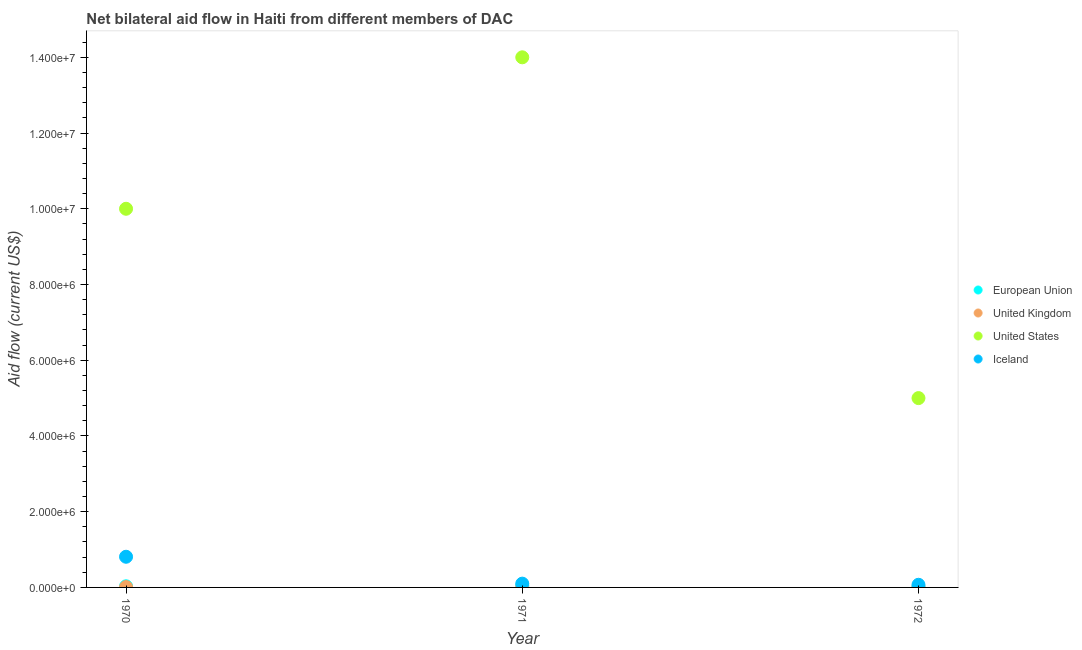What is the amount of aid given by us in 1972?
Keep it short and to the point. 5.00e+06. Across all years, what is the maximum amount of aid given by uk?
Provide a succinct answer. 10000. Across all years, what is the minimum amount of aid given by us?
Give a very brief answer. 5.00e+06. In which year was the amount of aid given by eu maximum?
Give a very brief answer. 1971. What is the total amount of aid given by eu in the graph?
Provide a succinct answer. 9.00e+04. What is the difference between the amount of aid given by iceland in 1970 and that in 1971?
Offer a terse response. 7.10e+05. What is the difference between the amount of aid given by iceland in 1972 and the amount of aid given by us in 1971?
Make the answer very short. -1.39e+07. What is the average amount of aid given by iceland per year?
Offer a very short reply. 3.27e+05. In the year 1970, what is the difference between the amount of aid given by uk and amount of aid given by us?
Ensure brevity in your answer.  -9.99e+06. What is the ratio of the amount of aid given by uk in 1970 to that in 1971?
Give a very brief answer. 1. Is the difference between the amount of aid given by eu in 1970 and 1971 greater than the difference between the amount of aid given by uk in 1970 and 1971?
Your answer should be compact. No. What is the difference between the highest and the second highest amount of aid given by eu?
Keep it short and to the point. 2.00e+04. Is the sum of the amount of aid given by iceland in 1970 and 1972 greater than the maximum amount of aid given by us across all years?
Ensure brevity in your answer.  No. Is it the case that in every year, the sum of the amount of aid given by uk and amount of aid given by iceland is greater than the sum of amount of aid given by eu and amount of aid given by us?
Your answer should be compact. Yes. Is the amount of aid given by eu strictly less than the amount of aid given by uk over the years?
Keep it short and to the point. No. How many years are there in the graph?
Offer a very short reply. 3. What is the difference between two consecutive major ticks on the Y-axis?
Your answer should be very brief. 2.00e+06. Are the values on the major ticks of Y-axis written in scientific E-notation?
Give a very brief answer. Yes. Where does the legend appear in the graph?
Your response must be concise. Center right. What is the title of the graph?
Provide a succinct answer. Net bilateral aid flow in Haiti from different members of DAC. What is the label or title of the X-axis?
Make the answer very short. Year. What is the label or title of the Y-axis?
Make the answer very short. Aid flow (current US$). What is the Aid flow (current US$) of United Kingdom in 1970?
Provide a succinct answer. 10000. What is the Aid flow (current US$) of United States in 1970?
Offer a terse response. 1.00e+07. What is the Aid flow (current US$) of Iceland in 1970?
Your response must be concise. 8.10e+05. What is the Aid flow (current US$) of United Kingdom in 1971?
Your answer should be compact. 10000. What is the Aid flow (current US$) of United States in 1971?
Keep it short and to the point. 1.40e+07. What is the Aid flow (current US$) of Iceland in 1971?
Provide a succinct answer. 1.00e+05. What is the Aid flow (current US$) in Iceland in 1972?
Provide a succinct answer. 7.00e+04. Across all years, what is the maximum Aid flow (current US$) of United States?
Your answer should be compact. 1.40e+07. Across all years, what is the maximum Aid flow (current US$) of Iceland?
Offer a terse response. 8.10e+05. Across all years, what is the minimum Aid flow (current US$) of European Union?
Provide a succinct answer. 10000. Across all years, what is the minimum Aid flow (current US$) of Iceland?
Provide a succinct answer. 7.00e+04. What is the total Aid flow (current US$) in United States in the graph?
Provide a succinct answer. 2.90e+07. What is the total Aid flow (current US$) in Iceland in the graph?
Keep it short and to the point. 9.80e+05. What is the difference between the Aid flow (current US$) in United States in 1970 and that in 1971?
Provide a short and direct response. -4.00e+06. What is the difference between the Aid flow (current US$) of Iceland in 1970 and that in 1971?
Provide a short and direct response. 7.10e+05. What is the difference between the Aid flow (current US$) of United Kingdom in 1970 and that in 1972?
Give a very brief answer. 0. What is the difference between the Aid flow (current US$) in Iceland in 1970 and that in 1972?
Your response must be concise. 7.40e+05. What is the difference between the Aid flow (current US$) of United States in 1971 and that in 1972?
Your answer should be very brief. 9.00e+06. What is the difference between the Aid flow (current US$) of European Union in 1970 and the Aid flow (current US$) of United Kingdom in 1971?
Offer a terse response. 2.00e+04. What is the difference between the Aid flow (current US$) of European Union in 1970 and the Aid flow (current US$) of United States in 1971?
Make the answer very short. -1.40e+07. What is the difference between the Aid flow (current US$) of European Union in 1970 and the Aid flow (current US$) of Iceland in 1971?
Ensure brevity in your answer.  -7.00e+04. What is the difference between the Aid flow (current US$) in United Kingdom in 1970 and the Aid flow (current US$) in United States in 1971?
Keep it short and to the point. -1.40e+07. What is the difference between the Aid flow (current US$) in United Kingdom in 1970 and the Aid flow (current US$) in Iceland in 1971?
Give a very brief answer. -9.00e+04. What is the difference between the Aid flow (current US$) in United States in 1970 and the Aid flow (current US$) in Iceland in 1971?
Ensure brevity in your answer.  9.90e+06. What is the difference between the Aid flow (current US$) of European Union in 1970 and the Aid flow (current US$) of United States in 1972?
Offer a very short reply. -4.97e+06. What is the difference between the Aid flow (current US$) of European Union in 1970 and the Aid flow (current US$) of Iceland in 1972?
Your answer should be very brief. -4.00e+04. What is the difference between the Aid flow (current US$) in United Kingdom in 1970 and the Aid flow (current US$) in United States in 1972?
Offer a very short reply. -4.99e+06. What is the difference between the Aid flow (current US$) in United States in 1970 and the Aid flow (current US$) in Iceland in 1972?
Give a very brief answer. 9.93e+06. What is the difference between the Aid flow (current US$) of European Union in 1971 and the Aid flow (current US$) of United States in 1972?
Your answer should be very brief. -4.95e+06. What is the difference between the Aid flow (current US$) in European Union in 1971 and the Aid flow (current US$) in Iceland in 1972?
Your answer should be very brief. -2.00e+04. What is the difference between the Aid flow (current US$) in United Kingdom in 1971 and the Aid flow (current US$) in United States in 1972?
Your answer should be compact. -4.99e+06. What is the difference between the Aid flow (current US$) in United States in 1971 and the Aid flow (current US$) in Iceland in 1972?
Provide a succinct answer. 1.39e+07. What is the average Aid flow (current US$) in United Kingdom per year?
Offer a terse response. 10000. What is the average Aid flow (current US$) in United States per year?
Keep it short and to the point. 9.67e+06. What is the average Aid flow (current US$) in Iceland per year?
Offer a terse response. 3.27e+05. In the year 1970, what is the difference between the Aid flow (current US$) of European Union and Aid flow (current US$) of United Kingdom?
Ensure brevity in your answer.  2.00e+04. In the year 1970, what is the difference between the Aid flow (current US$) of European Union and Aid flow (current US$) of United States?
Offer a terse response. -9.97e+06. In the year 1970, what is the difference between the Aid flow (current US$) of European Union and Aid flow (current US$) of Iceland?
Provide a succinct answer. -7.80e+05. In the year 1970, what is the difference between the Aid flow (current US$) of United Kingdom and Aid flow (current US$) of United States?
Offer a terse response. -9.99e+06. In the year 1970, what is the difference between the Aid flow (current US$) of United Kingdom and Aid flow (current US$) of Iceland?
Ensure brevity in your answer.  -8.00e+05. In the year 1970, what is the difference between the Aid flow (current US$) in United States and Aid flow (current US$) in Iceland?
Keep it short and to the point. 9.19e+06. In the year 1971, what is the difference between the Aid flow (current US$) of European Union and Aid flow (current US$) of United Kingdom?
Make the answer very short. 4.00e+04. In the year 1971, what is the difference between the Aid flow (current US$) of European Union and Aid flow (current US$) of United States?
Provide a succinct answer. -1.40e+07. In the year 1971, what is the difference between the Aid flow (current US$) in United Kingdom and Aid flow (current US$) in United States?
Your answer should be compact. -1.40e+07. In the year 1971, what is the difference between the Aid flow (current US$) of United States and Aid flow (current US$) of Iceland?
Your answer should be compact. 1.39e+07. In the year 1972, what is the difference between the Aid flow (current US$) in European Union and Aid flow (current US$) in United Kingdom?
Make the answer very short. 0. In the year 1972, what is the difference between the Aid flow (current US$) of European Union and Aid flow (current US$) of United States?
Keep it short and to the point. -4.99e+06. In the year 1972, what is the difference between the Aid flow (current US$) of United Kingdom and Aid flow (current US$) of United States?
Provide a short and direct response. -4.99e+06. In the year 1972, what is the difference between the Aid flow (current US$) in United Kingdom and Aid flow (current US$) in Iceland?
Your answer should be compact. -6.00e+04. In the year 1972, what is the difference between the Aid flow (current US$) of United States and Aid flow (current US$) of Iceland?
Your response must be concise. 4.93e+06. What is the ratio of the Aid flow (current US$) in European Union in 1970 to that in 1971?
Ensure brevity in your answer.  0.6. What is the ratio of the Aid flow (current US$) in United States in 1970 to that in 1971?
Offer a terse response. 0.71. What is the ratio of the Aid flow (current US$) of United Kingdom in 1970 to that in 1972?
Make the answer very short. 1. What is the ratio of the Aid flow (current US$) of United States in 1970 to that in 1972?
Ensure brevity in your answer.  2. What is the ratio of the Aid flow (current US$) of Iceland in 1970 to that in 1972?
Make the answer very short. 11.57. What is the ratio of the Aid flow (current US$) of European Union in 1971 to that in 1972?
Provide a short and direct response. 5. What is the ratio of the Aid flow (current US$) of Iceland in 1971 to that in 1972?
Give a very brief answer. 1.43. What is the difference between the highest and the second highest Aid flow (current US$) in United Kingdom?
Give a very brief answer. 0. What is the difference between the highest and the second highest Aid flow (current US$) in Iceland?
Your answer should be very brief. 7.10e+05. What is the difference between the highest and the lowest Aid flow (current US$) of United States?
Offer a very short reply. 9.00e+06. What is the difference between the highest and the lowest Aid flow (current US$) in Iceland?
Make the answer very short. 7.40e+05. 